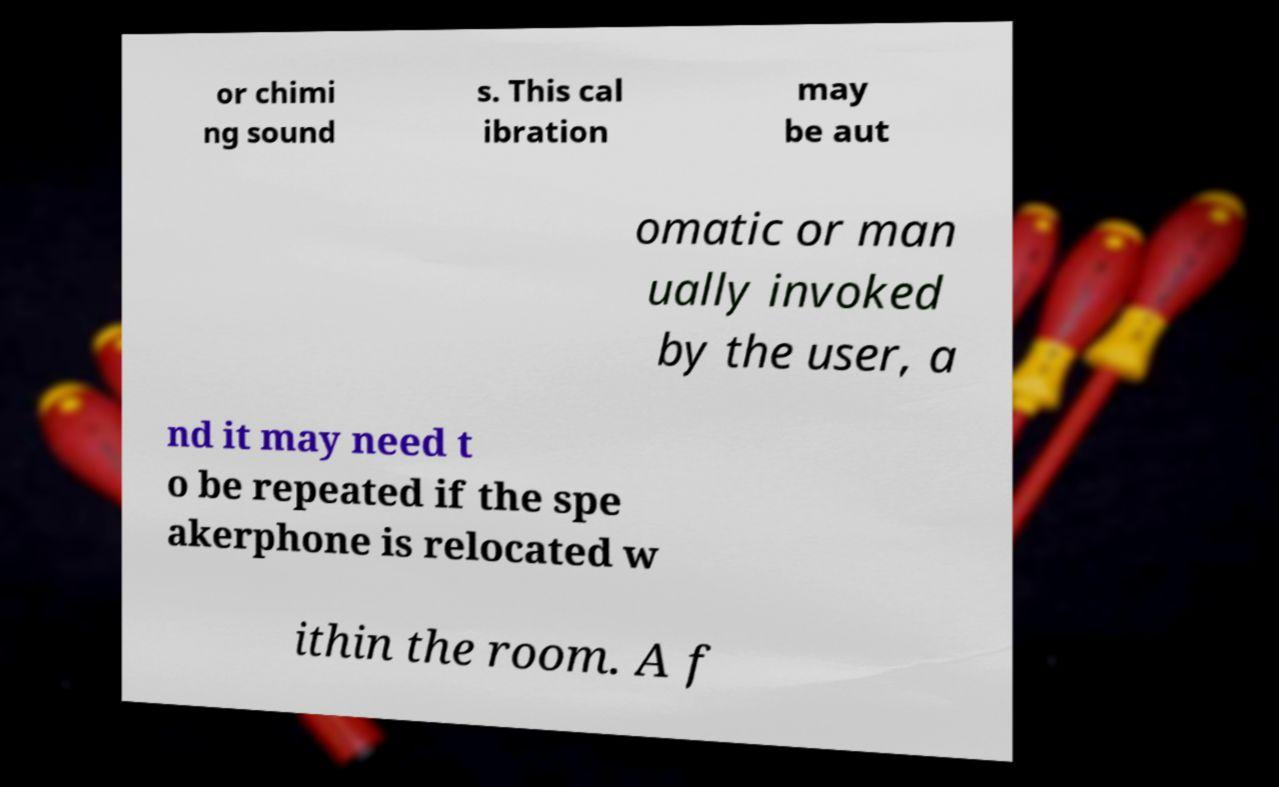Please read and relay the text visible in this image. What does it say? or chimi ng sound s. This cal ibration may be aut omatic or man ually invoked by the user, a nd it may need t o be repeated if the spe akerphone is relocated w ithin the room. A f 